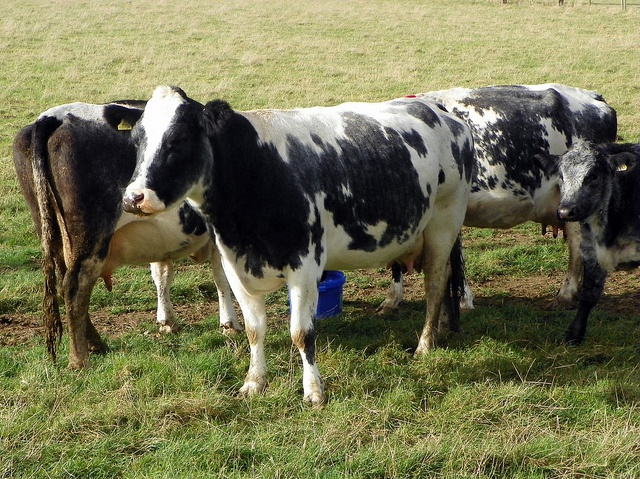Describe the objects in this image and their specific colors. I can see cow in tan, black, gray, white, and darkgray tones, cow in tan, black, olive, and gray tones, cow in tan, black, gray, darkgray, and ivory tones, and cow in tan, black, gray, darkgray, and darkgreen tones in this image. 